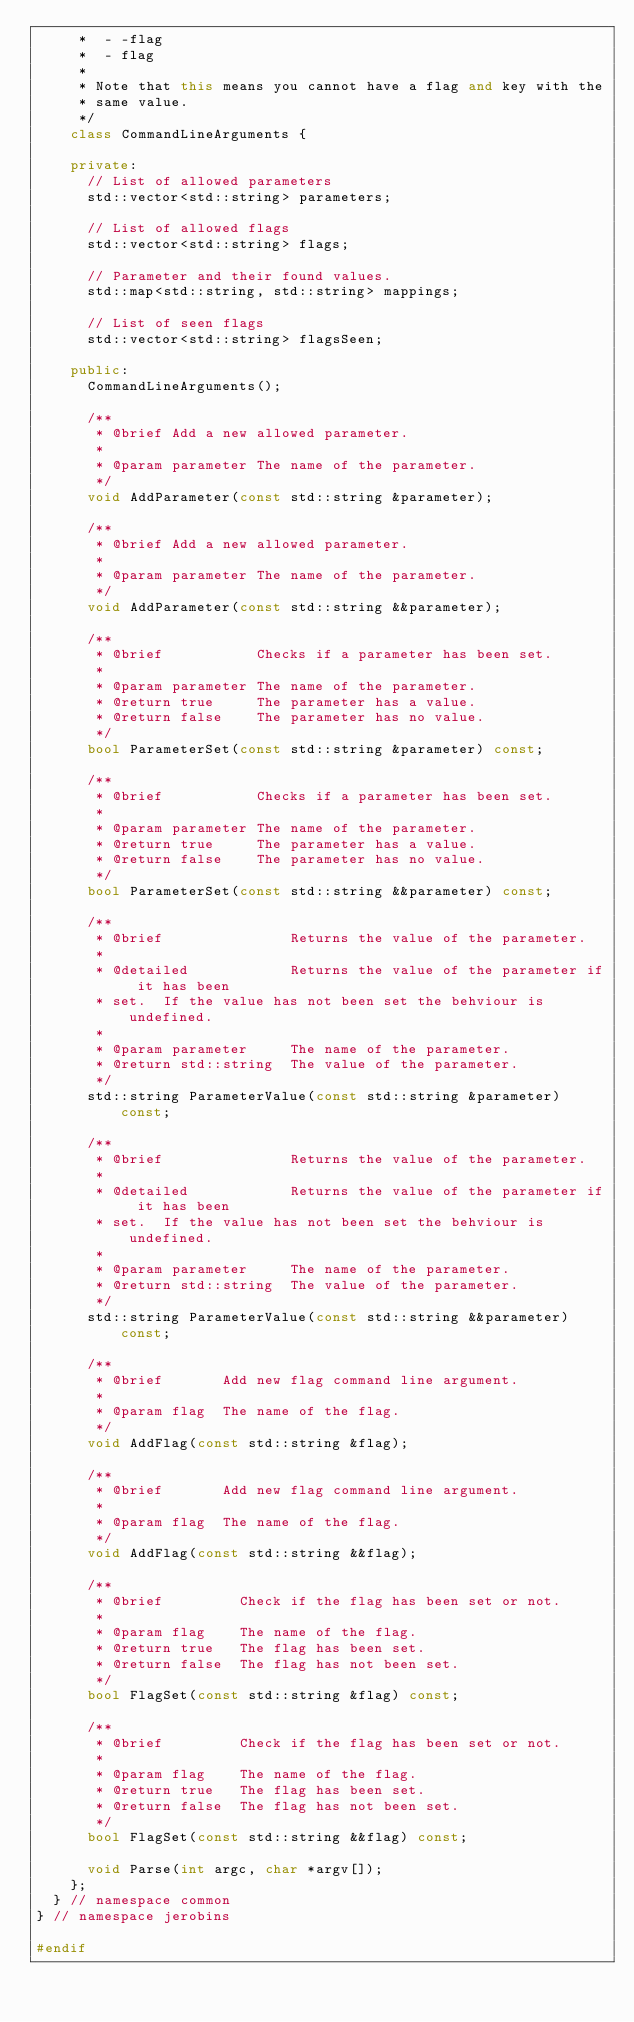Convert code to text. <code><loc_0><loc_0><loc_500><loc_500><_C++_>     *  - -flag
     *  - flag
     *
     * Note that this means you cannot have a flag and key with the
     * same value.
     */
    class CommandLineArguments {

    private:
      // List of allowed parameters
      std::vector<std::string> parameters;

      // List of allowed flags
      std::vector<std::string> flags;

      // Parameter and their found values.
      std::map<std::string, std::string> mappings;

      // List of seen flags
      std::vector<std::string> flagsSeen;

    public:
      CommandLineArguments();

      /**
       * @brief Add a new allowed parameter.
       *
       * @param parameter The name of the parameter.
       */
      void AddParameter(const std::string &parameter);

      /**
       * @brief Add a new allowed parameter.
       *
       * @param parameter The name of the parameter.
       */
      void AddParameter(const std::string &&parameter);

      /**
       * @brief           Checks if a parameter has been set.
       *
       * @param parameter The name of the parameter.
       * @return true     The parameter has a value.
       * @return false    The parameter has no value.
       */
      bool ParameterSet(const std::string &parameter) const;

      /**
       * @brief           Checks if a parameter has been set.
       *
       * @param parameter The name of the parameter.
       * @return true     The parameter has a value.
       * @return false    The parameter has no value.
       */
      bool ParameterSet(const std::string &&parameter) const;

      /**
       * @brief               Returns the value of the parameter.
       *
       * @detailed            Returns the value of the parameter if it has been
       * set.  If the value has not been set the behviour is undefined.
       *
       * @param parameter     The name of the parameter.
       * @return std::string  The value of the parameter.
       */
      std::string ParameterValue(const std::string &parameter) const;

      /**
       * @brief               Returns the value of the parameter.
       *
       * @detailed            Returns the value of the parameter if it has been
       * set.  If the value has not been set the behviour is undefined.
       *
       * @param parameter     The name of the parameter.
       * @return std::string  The value of the parameter.
       */
      std::string ParameterValue(const std::string &&parameter) const;

      /**
       * @brief       Add new flag command line argument.
       *
       * @param flag  The name of the flag.
       */
      void AddFlag(const std::string &flag);

      /**
       * @brief       Add new flag command line argument.
       *
       * @param flag  The name of the flag.
       */
      void AddFlag(const std::string &&flag);

      /**
       * @brief         Check if the flag has been set or not.
       *
       * @param flag    The name of the flag.
       * @return true   The flag has been set.
       * @return false  The flag has not been set.
       */
      bool FlagSet(const std::string &flag) const;

      /**
       * @brief         Check if the flag has been set or not.
       *
       * @param flag    The name of the flag.
       * @return true   The flag has been set.
       * @return false  The flag has not been set.
       */
      bool FlagSet(const std::string &&flag) const;

      void Parse(int argc, char *argv[]);
    };
  } // namespace common
} // namespace jerobins

#endif</code> 